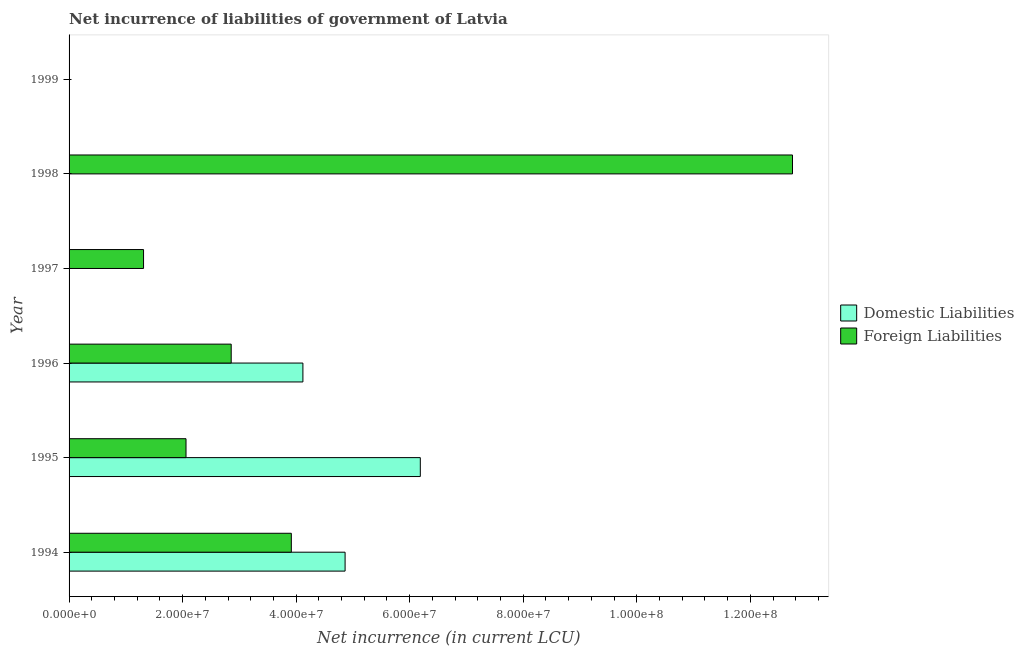How many different coloured bars are there?
Your answer should be very brief. 2. Are the number of bars per tick equal to the number of legend labels?
Offer a very short reply. No. Are the number of bars on each tick of the Y-axis equal?
Your response must be concise. No. How many bars are there on the 5th tick from the bottom?
Keep it short and to the point. 1. What is the label of the 6th group of bars from the top?
Ensure brevity in your answer.  1994. In how many cases, is the number of bars for a given year not equal to the number of legend labels?
Provide a short and direct response. 3. Across all years, what is the maximum net incurrence of domestic liabilities?
Your answer should be compact. 6.19e+07. In which year was the net incurrence of foreign liabilities maximum?
Provide a short and direct response. 1998. What is the total net incurrence of foreign liabilities in the graph?
Your answer should be very brief. 2.29e+08. What is the difference between the net incurrence of foreign liabilities in 1994 and that in 1995?
Provide a succinct answer. 1.86e+07. What is the difference between the net incurrence of domestic liabilities in 1995 and the net incurrence of foreign liabilities in 1996?
Your answer should be compact. 3.33e+07. What is the average net incurrence of domestic liabilities per year?
Keep it short and to the point. 2.53e+07. In the year 1994, what is the difference between the net incurrence of domestic liabilities and net incurrence of foreign liabilities?
Your answer should be very brief. 9.47e+06. What is the ratio of the net incurrence of domestic liabilities in 1994 to that in 1995?
Give a very brief answer. 0.79. Is the net incurrence of foreign liabilities in 1995 less than that in 1996?
Your answer should be compact. Yes. What is the difference between the highest and the second highest net incurrence of domestic liabilities?
Offer a very short reply. 1.32e+07. What is the difference between the highest and the lowest net incurrence of domestic liabilities?
Your answer should be very brief. 6.19e+07. In how many years, is the net incurrence of foreign liabilities greater than the average net incurrence of foreign liabilities taken over all years?
Your answer should be compact. 2. How many bars are there?
Give a very brief answer. 8. Are all the bars in the graph horizontal?
Provide a succinct answer. Yes. How many years are there in the graph?
Provide a short and direct response. 6. Are the values on the major ticks of X-axis written in scientific E-notation?
Offer a terse response. Yes. What is the title of the graph?
Make the answer very short. Net incurrence of liabilities of government of Latvia. What is the label or title of the X-axis?
Offer a terse response. Net incurrence (in current LCU). What is the label or title of the Y-axis?
Ensure brevity in your answer.  Year. What is the Net incurrence (in current LCU) of Domestic Liabilities in 1994?
Provide a succinct answer. 4.86e+07. What is the Net incurrence (in current LCU) of Foreign Liabilities in 1994?
Give a very brief answer. 3.92e+07. What is the Net incurrence (in current LCU) in Domestic Liabilities in 1995?
Your response must be concise. 6.19e+07. What is the Net incurrence (in current LCU) in Foreign Liabilities in 1995?
Give a very brief answer. 2.06e+07. What is the Net incurrence (in current LCU) in Domestic Liabilities in 1996?
Provide a short and direct response. 4.12e+07. What is the Net incurrence (in current LCU) of Foreign Liabilities in 1996?
Provide a short and direct response. 2.86e+07. What is the Net incurrence (in current LCU) of Foreign Liabilities in 1997?
Provide a succinct answer. 1.31e+07. What is the Net incurrence (in current LCU) of Domestic Liabilities in 1998?
Give a very brief answer. 0. What is the Net incurrence (in current LCU) of Foreign Liabilities in 1998?
Make the answer very short. 1.27e+08. What is the Net incurrence (in current LCU) of Foreign Liabilities in 1999?
Your answer should be very brief. 0. Across all years, what is the maximum Net incurrence (in current LCU) of Domestic Liabilities?
Provide a succinct answer. 6.19e+07. Across all years, what is the maximum Net incurrence (in current LCU) in Foreign Liabilities?
Make the answer very short. 1.27e+08. Across all years, what is the minimum Net incurrence (in current LCU) of Domestic Liabilities?
Your response must be concise. 0. What is the total Net incurrence (in current LCU) of Domestic Liabilities in the graph?
Give a very brief answer. 1.52e+08. What is the total Net incurrence (in current LCU) of Foreign Liabilities in the graph?
Your answer should be very brief. 2.29e+08. What is the difference between the Net incurrence (in current LCU) in Domestic Liabilities in 1994 and that in 1995?
Give a very brief answer. -1.32e+07. What is the difference between the Net incurrence (in current LCU) of Foreign Liabilities in 1994 and that in 1995?
Offer a very short reply. 1.86e+07. What is the difference between the Net incurrence (in current LCU) in Domestic Liabilities in 1994 and that in 1996?
Your answer should be compact. 7.43e+06. What is the difference between the Net incurrence (in current LCU) of Foreign Liabilities in 1994 and that in 1996?
Give a very brief answer. 1.06e+07. What is the difference between the Net incurrence (in current LCU) of Foreign Liabilities in 1994 and that in 1997?
Your response must be concise. 2.60e+07. What is the difference between the Net incurrence (in current LCU) in Foreign Liabilities in 1994 and that in 1998?
Your response must be concise. -8.83e+07. What is the difference between the Net incurrence (in current LCU) of Domestic Liabilities in 1995 and that in 1996?
Keep it short and to the point. 2.07e+07. What is the difference between the Net incurrence (in current LCU) of Foreign Liabilities in 1995 and that in 1996?
Provide a short and direct response. -7.96e+06. What is the difference between the Net incurrence (in current LCU) in Foreign Liabilities in 1995 and that in 1997?
Your answer should be very brief. 7.48e+06. What is the difference between the Net incurrence (in current LCU) of Foreign Liabilities in 1995 and that in 1998?
Your answer should be very brief. -1.07e+08. What is the difference between the Net incurrence (in current LCU) of Foreign Liabilities in 1996 and that in 1997?
Your answer should be compact. 1.54e+07. What is the difference between the Net incurrence (in current LCU) of Foreign Liabilities in 1996 and that in 1998?
Provide a succinct answer. -9.89e+07. What is the difference between the Net incurrence (in current LCU) of Foreign Liabilities in 1997 and that in 1998?
Ensure brevity in your answer.  -1.14e+08. What is the difference between the Net incurrence (in current LCU) of Domestic Liabilities in 1994 and the Net incurrence (in current LCU) of Foreign Liabilities in 1995?
Ensure brevity in your answer.  2.80e+07. What is the difference between the Net incurrence (in current LCU) of Domestic Liabilities in 1994 and the Net incurrence (in current LCU) of Foreign Liabilities in 1996?
Ensure brevity in your answer.  2.01e+07. What is the difference between the Net incurrence (in current LCU) in Domestic Liabilities in 1994 and the Net incurrence (in current LCU) in Foreign Liabilities in 1997?
Your answer should be very brief. 3.55e+07. What is the difference between the Net incurrence (in current LCU) of Domestic Liabilities in 1994 and the Net incurrence (in current LCU) of Foreign Liabilities in 1998?
Offer a terse response. -7.88e+07. What is the difference between the Net incurrence (in current LCU) in Domestic Liabilities in 1995 and the Net incurrence (in current LCU) in Foreign Liabilities in 1996?
Keep it short and to the point. 3.33e+07. What is the difference between the Net incurrence (in current LCU) of Domestic Liabilities in 1995 and the Net incurrence (in current LCU) of Foreign Liabilities in 1997?
Offer a terse response. 4.88e+07. What is the difference between the Net incurrence (in current LCU) of Domestic Liabilities in 1995 and the Net incurrence (in current LCU) of Foreign Liabilities in 1998?
Provide a succinct answer. -6.56e+07. What is the difference between the Net incurrence (in current LCU) of Domestic Liabilities in 1996 and the Net incurrence (in current LCU) of Foreign Liabilities in 1997?
Give a very brief answer. 2.81e+07. What is the difference between the Net incurrence (in current LCU) in Domestic Liabilities in 1996 and the Net incurrence (in current LCU) in Foreign Liabilities in 1998?
Provide a succinct answer. -8.62e+07. What is the average Net incurrence (in current LCU) of Domestic Liabilities per year?
Ensure brevity in your answer.  2.53e+07. What is the average Net incurrence (in current LCU) of Foreign Liabilities per year?
Provide a short and direct response. 3.81e+07. In the year 1994, what is the difference between the Net incurrence (in current LCU) in Domestic Liabilities and Net incurrence (in current LCU) in Foreign Liabilities?
Offer a terse response. 9.47e+06. In the year 1995, what is the difference between the Net incurrence (in current LCU) of Domestic Liabilities and Net incurrence (in current LCU) of Foreign Liabilities?
Offer a very short reply. 4.13e+07. In the year 1996, what is the difference between the Net incurrence (in current LCU) in Domestic Liabilities and Net incurrence (in current LCU) in Foreign Liabilities?
Your response must be concise. 1.26e+07. What is the ratio of the Net incurrence (in current LCU) in Domestic Liabilities in 1994 to that in 1995?
Your answer should be compact. 0.79. What is the ratio of the Net incurrence (in current LCU) in Foreign Liabilities in 1994 to that in 1995?
Provide a succinct answer. 1.9. What is the ratio of the Net incurrence (in current LCU) of Domestic Liabilities in 1994 to that in 1996?
Your answer should be very brief. 1.18. What is the ratio of the Net incurrence (in current LCU) of Foreign Liabilities in 1994 to that in 1996?
Offer a terse response. 1.37. What is the ratio of the Net incurrence (in current LCU) of Foreign Liabilities in 1994 to that in 1997?
Your answer should be very brief. 2.98. What is the ratio of the Net incurrence (in current LCU) of Foreign Liabilities in 1994 to that in 1998?
Offer a very short reply. 0.31. What is the ratio of the Net incurrence (in current LCU) in Domestic Liabilities in 1995 to that in 1996?
Your response must be concise. 1.5. What is the ratio of the Net incurrence (in current LCU) in Foreign Liabilities in 1995 to that in 1996?
Keep it short and to the point. 0.72. What is the ratio of the Net incurrence (in current LCU) in Foreign Liabilities in 1995 to that in 1997?
Offer a terse response. 1.57. What is the ratio of the Net incurrence (in current LCU) of Foreign Liabilities in 1995 to that in 1998?
Your response must be concise. 0.16. What is the ratio of the Net incurrence (in current LCU) of Foreign Liabilities in 1996 to that in 1997?
Offer a very short reply. 2.18. What is the ratio of the Net incurrence (in current LCU) of Foreign Liabilities in 1996 to that in 1998?
Provide a short and direct response. 0.22. What is the ratio of the Net incurrence (in current LCU) of Foreign Liabilities in 1997 to that in 1998?
Give a very brief answer. 0.1. What is the difference between the highest and the second highest Net incurrence (in current LCU) of Domestic Liabilities?
Offer a terse response. 1.32e+07. What is the difference between the highest and the second highest Net incurrence (in current LCU) in Foreign Liabilities?
Provide a short and direct response. 8.83e+07. What is the difference between the highest and the lowest Net incurrence (in current LCU) in Domestic Liabilities?
Provide a short and direct response. 6.19e+07. What is the difference between the highest and the lowest Net incurrence (in current LCU) of Foreign Liabilities?
Ensure brevity in your answer.  1.27e+08. 